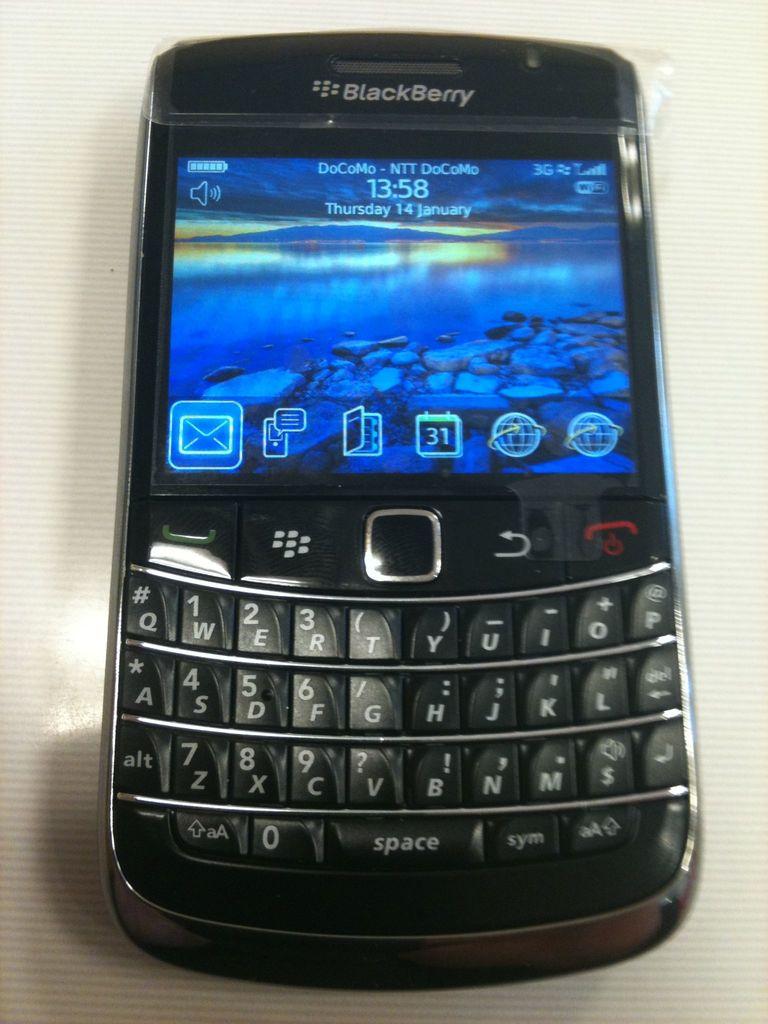What type of phone is this?
Ensure brevity in your answer.  Blackberry. What time is it?
Offer a very short reply. 13:58. 